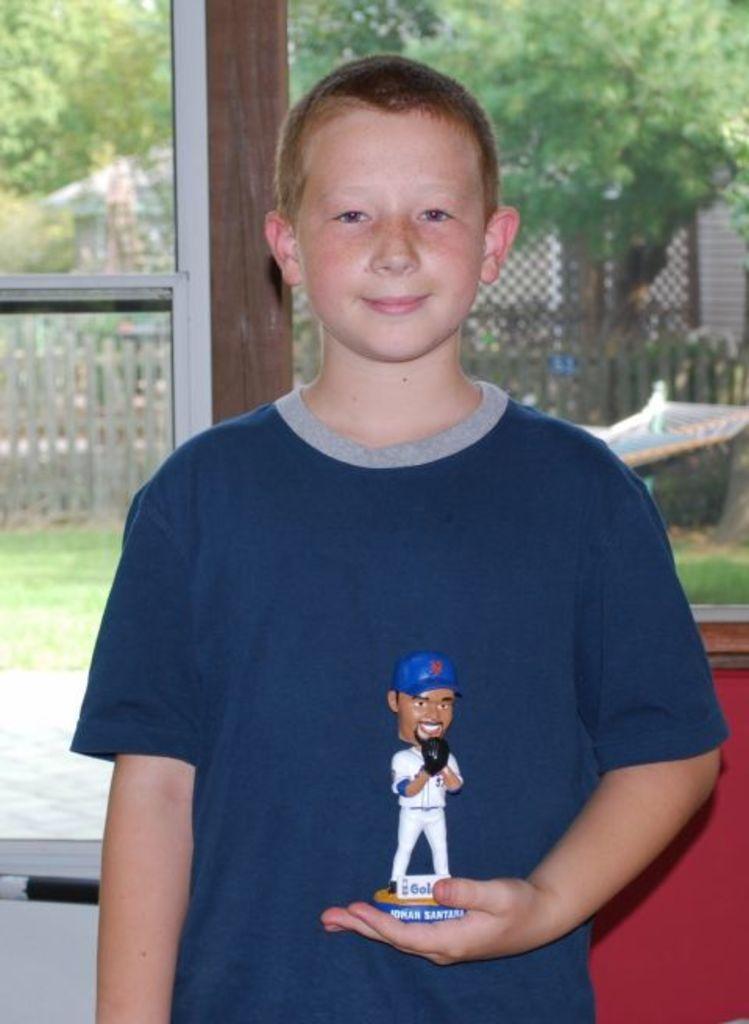Can you describe this image briefly? In the image there is a boy standing and he is holding some toy in his hand, behind the boy there is a window and behind the window there is a fencing and trees. 